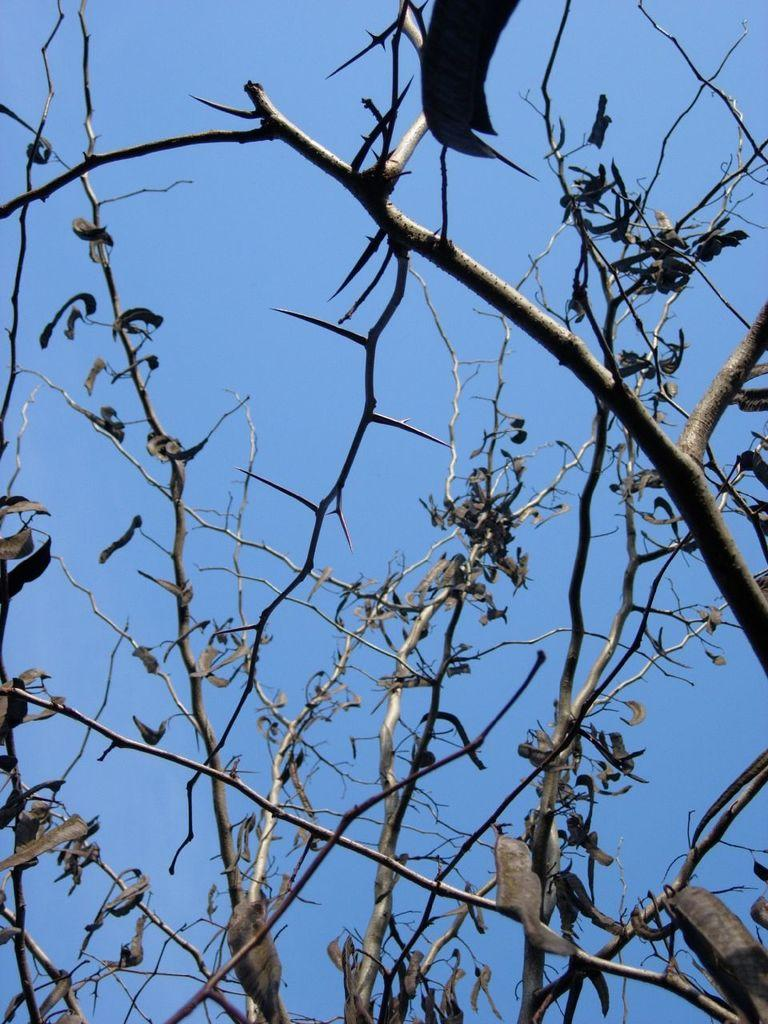What is the main subject of the image? The main subject of the image is a group of leaves. What else can be seen in the image besides the leaves? There are branches of a tree in the image. What is visible in the background of the image? The sky is visible in the background of the image. How many degrees can be seen in the image? There are no degrees visible in the image; it features a group of leaves, tree branches, and the sky. 